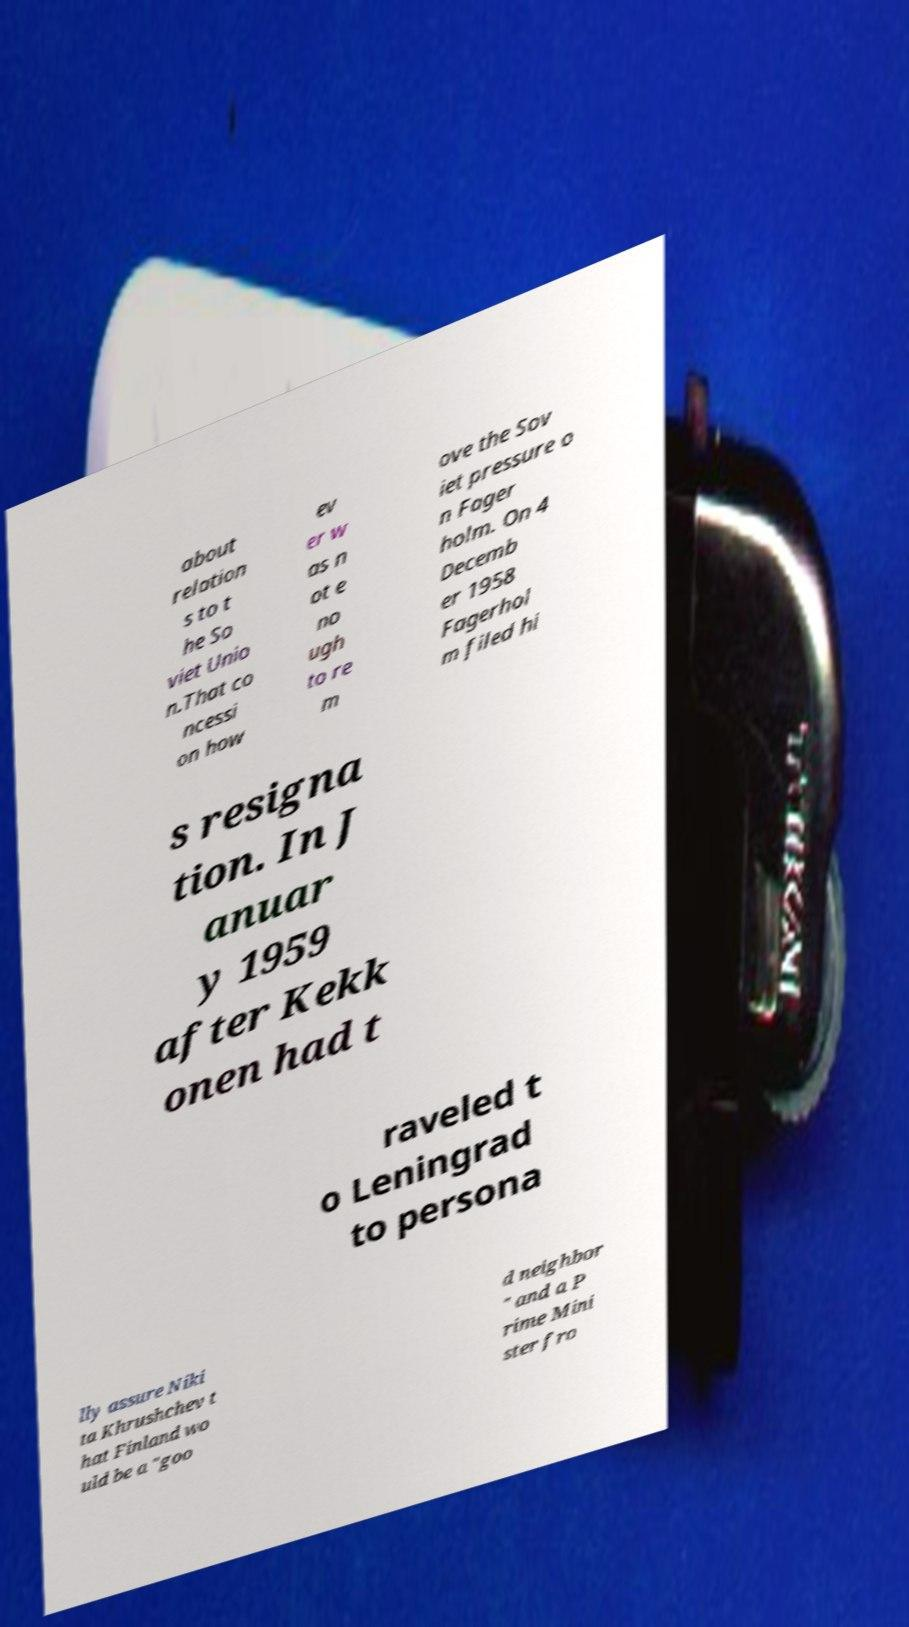Can you read and provide the text displayed in the image?This photo seems to have some interesting text. Can you extract and type it out for me? about relation s to t he So viet Unio n.That co ncessi on how ev er w as n ot e no ugh to re m ove the Sov iet pressure o n Fager holm. On 4 Decemb er 1958 Fagerhol m filed hi s resigna tion. In J anuar y 1959 after Kekk onen had t raveled t o Leningrad to persona lly assure Niki ta Khrushchev t hat Finland wo uld be a "goo d neighbor " and a P rime Mini ster fro 